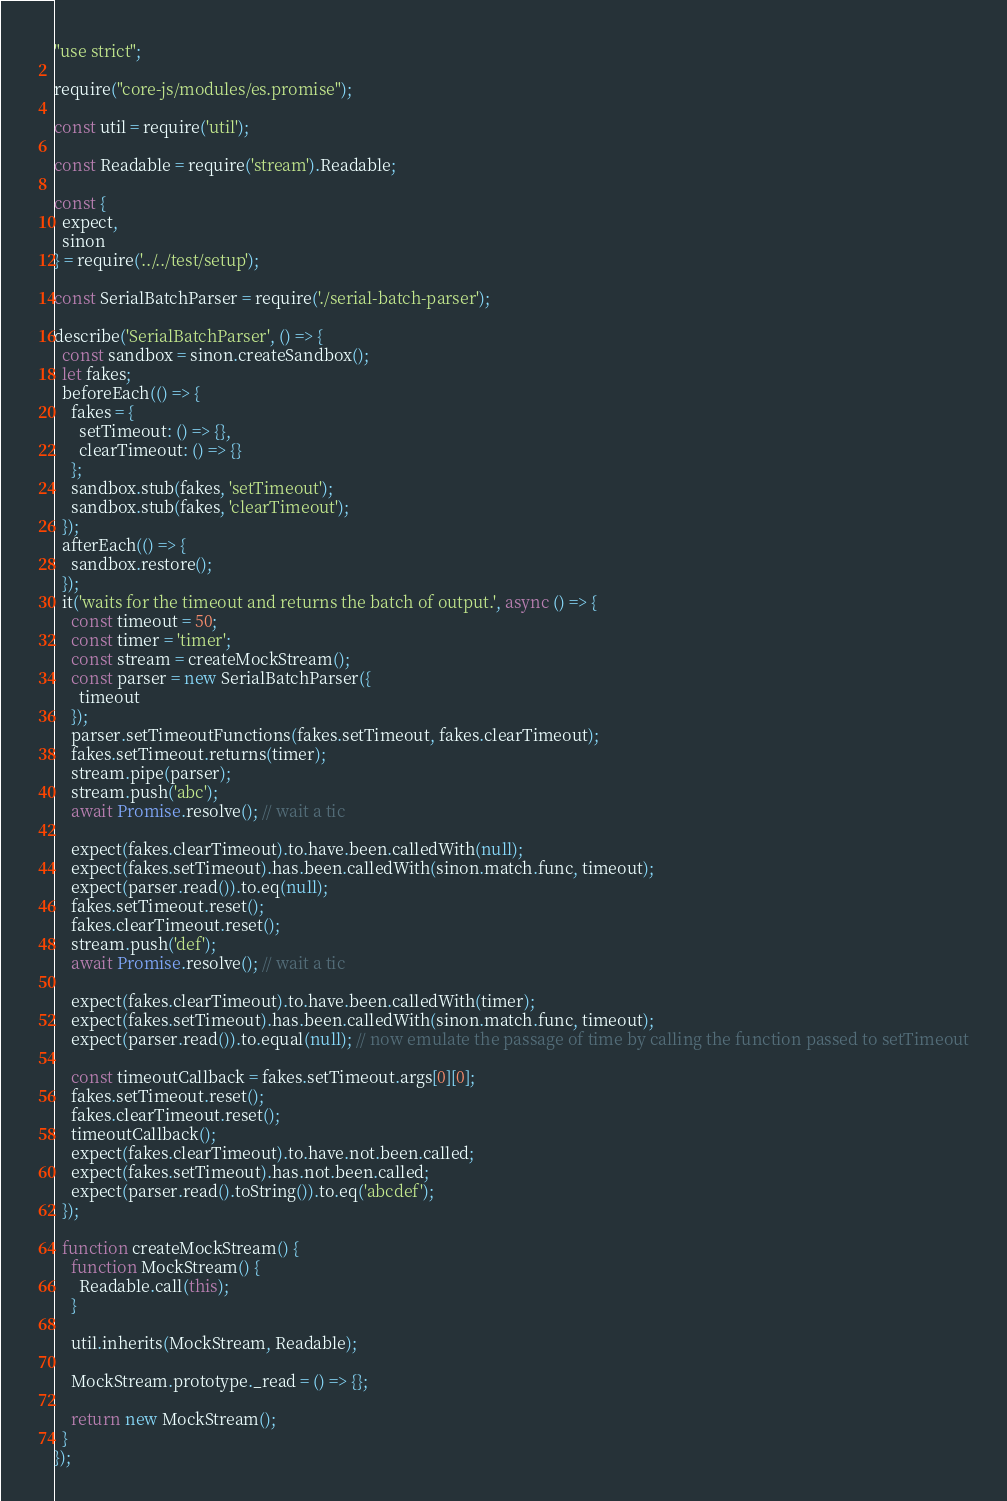Convert code to text. <code><loc_0><loc_0><loc_500><loc_500><_JavaScript_>"use strict";

require("core-js/modules/es.promise");

const util = require('util');

const Readable = require('stream').Readable;

const {
  expect,
  sinon
} = require('../../test/setup');

const SerialBatchParser = require('./serial-batch-parser');

describe('SerialBatchParser', () => {
  const sandbox = sinon.createSandbox();
  let fakes;
  beforeEach(() => {
    fakes = {
      setTimeout: () => {},
      clearTimeout: () => {}
    };
    sandbox.stub(fakes, 'setTimeout');
    sandbox.stub(fakes, 'clearTimeout');
  });
  afterEach(() => {
    sandbox.restore();
  });
  it('waits for the timeout and returns the batch of output.', async () => {
    const timeout = 50;
    const timer = 'timer';
    const stream = createMockStream();
    const parser = new SerialBatchParser({
      timeout
    });
    parser.setTimeoutFunctions(fakes.setTimeout, fakes.clearTimeout);
    fakes.setTimeout.returns(timer);
    stream.pipe(parser);
    stream.push('abc');
    await Promise.resolve(); // wait a tic

    expect(fakes.clearTimeout).to.have.been.calledWith(null);
    expect(fakes.setTimeout).has.been.calledWith(sinon.match.func, timeout);
    expect(parser.read()).to.eq(null);
    fakes.setTimeout.reset();
    fakes.clearTimeout.reset();
    stream.push('def');
    await Promise.resolve(); // wait a tic

    expect(fakes.clearTimeout).to.have.been.calledWith(timer);
    expect(fakes.setTimeout).has.been.calledWith(sinon.match.func, timeout);
    expect(parser.read()).to.equal(null); // now emulate the passage of time by calling the function passed to setTimeout

    const timeoutCallback = fakes.setTimeout.args[0][0];
    fakes.setTimeout.reset();
    fakes.clearTimeout.reset();
    timeoutCallback();
    expect(fakes.clearTimeout).to.have.not.been.called;
    expect(fakes.setTimeout).has.not.been.called;
    expect(parser.read().toString()).to.eq('abcdef');
  });

  function createMockStream() {
    function MockStream() {
      Readable.call(this);
    }

    util.inherits(MockStream, Readable);

    MockStream.prototype._read = () => {};

    return new MockStream();
  }
});</code> 